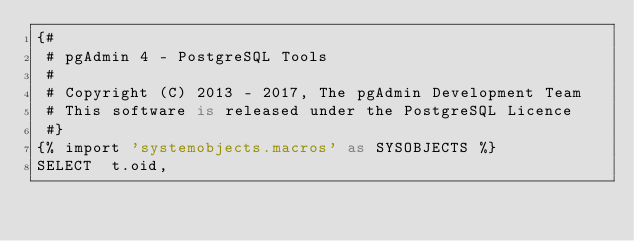<code> <loc_0><loc_0><loc_500><loc_500><_SQL_>{#
 # pgAdmin 4 - PostgreSQL Tools
 #
 # Copyright (C) 2013 - 2017, The pgAdmin Development Team
 # This software is released under the PostgreSQL Licence
 #}
{% import 'systemobjects.macros' as SYSOBJECTS %}
SELECT  t.oid,</code> 